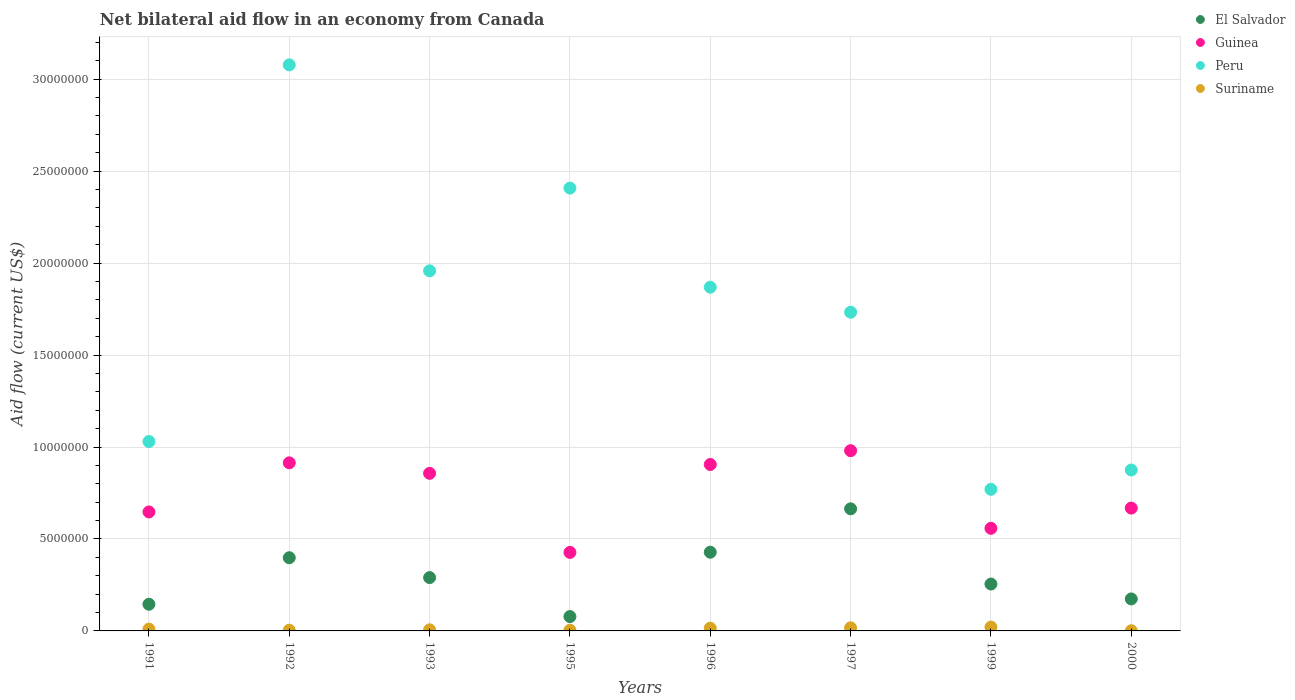Is the number of dotlines equal to the number of legend labels?
Offer a very short reply. Yes. What is the net bilateral aid flow in Peru in 1992?
Provide a short and direct response. 3.08e+07. Across all years, what is the maximum net bilateral aid flow in Suriname?
Provide a short and direct response. 2.10e+05. Across all years, what is the minimum net bilateral aid flow in Peru?
Your response must be concise. 7.70e+06. In which year was the net bilateral aid flow in Guinea minimum?
Your answer should be very brief. 1995. What is the total net bilateral aid flow in Guinea in the graph?
Your answer should be compact. 5.96e+07. What is the difference between the net bilateral aid flow in El Salvador in 1992 and that in 2000?
Offer a very short reply. 2.24e+06. What is the difference between the net bilateral aid flow in El Salvador in 1993 and the net bilateral aid flow in Peru in 1995?
Provide a short and direct response. -2.12e+07. What is the average net bilateral aid flow in Guinea per year?
Provide a succinct answer. 7.44e+06. In the year 1995, what is the difference between the net bilateral aid flow in Guinea and net bilateral aid flow in El Salvador?
Give a very brief answer. 3.49e+06. What is the ratio of the net bilateral aid flow in Peru in 1991 to that in 1999?
Give a very brief answer. 1.34. Is the difference between the net bilateral aid flow in Guinea in 1995 and 1999 greater than the difference between the net bilateral aid flow in El Salvador in 1995 and 1999?
Offer a very short reply. Yes. What is the difference between the highest and the second highest net bilateral aid flow in El Salvador?
Your answer should be compact. 2.36e+06. What is the difference between the highest and the lowest net bilateral aid flow in El Salvador?
Ensure brevity in your answer.  5.86e+06. Is the sum of the net bilateral aid flow in El Salvador in 1996 and 1997 greater than the maximum net bilateral aid flow in Suriname across all years?
Your answer should be very brief. Yes. Is it the case that in every year, the sum of the net bilateral aid flow in Guinea and net bilateral aid flow in Peru  is greater than the sum of net bilateral aid flow in El Salvador and net bilateral aid flow in Suriname?
Your answer should be very brief. Yes. Is the net bilateral aid flow in Guinea strictly greater than the net bilateral aid flow in Suriname over the years?
Your answer should be very brief. Yes. Is the net bilateral aid flow in Guinea strictly less than the net bilateral aid flow in Peru over the years?
Ensure brevity in your answer.  Yes. How many dotlines are there?
Offer a very short reply. 4. How many years are there in the graph?
Provide a short and direct response. 8. What is the difference between two consecutive major ticks on the Y-axis?
Your answer should be very brief. 5.00e+06. Does the graph contain any zero values?
Provide a succinct answer. No. Does the graph contain grids?
Your answer should be very brief. Yes. How many legend labels are there?
Make the answer very short. 4. What is the title of the graph?
Offer a terse response. Net bilateral aid flow in an economy from Canada. Does "Papua New Guinea" appear as one of the legend labels in the graph?
Keep it short and to the point. No. What is the label or title of the X-axis?
Ensure brevity in your answer.  Years. What is the Aid flow (current US$) of El Salvador in 1991?
Your response must be concise. 1.45e+06. What is the Aid flow (current US$) of Guinea in 1991?
Provide a succinct answer. 6.47e+06. What is the Aid flow (current US$) of Peru in 1991?
Your answer should be compact. 1.03e+07. What is the Aid flow (current US$) in Suriname in 1991?
Keep it short and to the point. 1.00e+05. What is the Aid flow (current US$) of El Salvador in 1992?
Your answer should be compact. 3.98e+06. What is the Aid flow (current US$) in Guinea in 1992?
Give a very brief answer. 9.14e+06. What is the Aid flow (current US$) of Peru in 1992?
Offer a terse response. 3.08e+07. What is the Aid flow (current US$) of El Salvador in 1993?
Give a very brief answer. 2.90e+06. What is the Aid flow (current US$) in Guinea in 1993?
Provide a succinct answer. 8.57e+06. What is the Aid flow (current US$) of Peru in 1993?
Give a very brief answer. 1.96e+07. What is the Aid flow (current US$) of Suriname in 1993?
Offer a terse response. 6.00e+04. What is the Aid flow (current US$) of El Salvador in 1995?
Make the answer very short. 7.80e+05. What is the Aid flow (current US$) of Guinea in 1995?
Your response must be concise. 4.27e+06. What is the Aid flow (current US$) of Peru in 1995?
Offer a terse response. 2.41e+07. What is the Aid flow (current US$) of Suriname in 1995?
Provide a short and direct response. 4.00e+04. What is the Aid flow (current US$) in El Salvador in 1996?
Your answer should be compact. 4.28e+06. What is the Aid flow (current US$) of Guinea in 1996?
Provide a short and direct response. 9.05e+06. What is the Aid flow (current US$) of Peru in 1996?
Give a very brief answer. 1.87e+07. What is the Aid flow (current US$) of El Salvador in 1997?
Provide a short and direct response. 6.64e+06. What is the Aid flow (current US$) in Guinea in 1997?
Offer a terse response. 9.80e+06. What is the Aid flow (current US$) in Peru in 1997?
Make the answer very short. 1.73e+07. What is the Aid flow (current US$) in Suriname in 1997?
Ensure brevity in your answer.  1.70e+05. What is the Aid flow (current US$) in El Salvador in 1999?
Provide a short and direct response. 2.55e+06. What is the Aid flow (current US$) of Guinea in 1999?
Provide a short and direct response. 5.58e+06. What is the Aid flow (current US$) of Peru in 1999?
Make the answer very short. 7.70e+06. What is the Aid flow (current US$) of Suriname in 1999?
Ensure brevity in your answer.  2.10e+05. What is the Aid flow (current US$) of El Salvador in 2000?
Offer a very short reply. 1.74e+06. What is the Aid flow (current US$) of Guinea in 2000?
Your response must be concise. 6.68e+06. What is the Aid flow (current US$) of Peru in 2000?
Offer a very short reply. 8.75e+06. Across all years, what is the maximum Aid flow (current US$) in El Salvador?
Give a very brief answer. 6.64e+06. Across all years, what is the maximum Aid flow (current US$) of Guinea?
Make the answer very short. 9.80e+06. Across all years, what is the maximum Aid flow (current US$) of Peru?
Your answer should be compact. 3.08e+07. Across all years, what is the maximum Aid flow (current US$) of Suriname?
Provide a short and direct response. 2.10e+05. Across all years, what is the minimum Aid flow (current US$) of El Salvador?
Provide a short and direct response. 7.80e+05. Across all years, what is the minimum Aid flow (current US$) in Guinea?
Provide a short and direct response. 4.27e+06. Across all years, what is the minimum Aid flow (current US$) in Peru?
Provide a succinct answer. 7.70e+06. What is the total Aid flow (current US$) of El Salvador in the graph?
Provide a succinct answer. 2.43e+07. What is the total Aid flow (current US$) of Guinea in the graph?
Your response must be concise. 5.96e+07. What is the total Aid flow (current US$) of Peru in the graph?
Ensure brevity in your answer.  1.37e+08. What is the total Aid flow (current US$) in Suriname in the graph?
Provide a succinct answer. 7.80e+05. What is the difference between the Aid flow (current US$) of El Salvador in 1991 and that in 1992?
Provide a succinct answer. -2.53e+06. What is the difference between the Aid flow (current US$) in Guinea in 1991 and that in 1992?
Provide a succinct answer. -2.67e+06. What is the difference between the Aid flow (current US$) in Peru in 1991 and that in 1992?
Provide a succinct answer. -2.05e+07. What is the difference between the Aid flow (current US$) in El Salvador in 1991 and that in 1993?
Provide a succinct answer. -1.45e+06. What is the difference between the Aid flow (current US$) in Guinea in 1991 and that in 1993?
Provide a short and direct response. -2.10e+06. What is the difference between the Aid flow (current US$) in Peru in 1991 and that in 1993?
Offer a terse response. -9.28e+06. What is the difference between the Aid flow (current US$) in Suriname in 1991 and that in 1993?
Provide a succinct answer. 4.00e+04. What is the difference between the Aid flow (current US$) in El Salvador in 1991 and that in 1995?
Give a very brief answer. 6.70e+05. What is the difference between the Aid flow (current US$) in Guinea in 1991 and that in 1995?
Provide a short and direct response. 2.20e+06. What is the difference between the Aid flow (current US$) in Peru in 1991 and that in 1995?
Ensure brevity in your answer.  -1.38e+07. What is the difference between the Aid flow (current US$) in Suriname in 1991 and that in 1995?
Offer a terse response. 6.00e+04. What is the difference between the Aid flow (current US$) of El Salvador in 1991 and that in 1996?
Offer a very short reply. -2.83e+06. What is the difference between the Aid flow (current US$) in Guinea in 1991 and that in 1996?
Your response must be concise. -2.58e+06. What is the difference between the Aid flow (current US$) of Peru in 1991 and that in 1996?
Your response must be concise. -8.39e+06. What is the difference between the Aid flow (current US$) in El Salvador in 1991 and that in 1997?
Offer a very short reply. -5.19e+06. What is the difference between the Aid flow (current US$) in Guinea in 1991 and that in 1997?
Offer a very short reply. -3.33e+06. What is the difference between the Aid flow (current US$) of Peru in 1991 and that in 1997?
Provide a succinct answer. -7.03e+06. What is the difference between the Aid flow (current US$) of Suriname in 1991 and that in 1997?
Provide a short and direct response. -7.00e+04. What is the difference between the Aid flow (current US$) in El Salvador in 1991 and that in 1999?
Your answer should be very brief. -1.10e+06. What is the difference between the Aid flow (current US$) of Guinea in 1991 and that in 1999?
Provide a short and direct response. 8.90e+05. What is the difference between the Aid flow (current US$) in Peru in 1991 and that in 1999?
Offer a very short reply. 2.60e+06. What is the difference between the Aid flow (current US$) in Suriname in 1991 and that in 1999?
Give a very brief answer. -1.10e+05. What is the difference between the Aid flow (current US$) of Peru in 1991 and that in 2000?
Your answer should be very brief. 1.55e+06. What is the difference between the Aid flow (current US$) of Suriname in 1991 and that in 2000?
Ensure brevity in your answer.  9.00e+04. What is the difference between the Aid flow (current US$) of El Salvador in 1992 and that in 1993?
Give a very brief answer. 1.08e+06. What is the difference between the Aid flow (current US$) of Guinea in 1992 and that in 1993?
Provide a short and direct response. 5.70e+05. What is the difference between the Aid flow (current US$) of Peru in 1992 and that in 1993?
Keep it short and to the point. 1.12e+07. What is the difference between the Aid flow (current US$) in El Salvador in 1992 and that in 1995?
Keep it short and to the point. 3.20e+06. What is the difference between the Aid flow (current US$) of Guinea in 1992 and that in 1995?
Keep it short and to the point. 4.87e+06. What is the difference between the Aid flow (current US$) in Peru in 1992 and that in 1995?
Your answer should be very brief. 6.70e+06. What is the difference between the Aid flow (current US$) of Suriname in 1992 and that in 1995?
Make the answer very short. 0. What is the difference between the Aid flow (current US$) in Peru in 1992 and that in 1996?
Make the answer very short. 1.21e+07. What is the difference between the Aid flow (current US$) in El Salvador in 1992 and that in 1997?
Ensure brevity in your answer.  -2.66e+06. What is the difference between the Aid flow (current US$) of Guinea in 1992 and that in 1997?
Ensure brevity in your answer.  -6.60e+05. What is the difference between the Aid flow (current US$) in Peru in 1992 and that in 1997?
Your answer should be compact. 1.34e+07. What is the difference between the Aid flow (current US$) in Suriname in 1992 and that in 1997?
Give a very brief answer. -1.30e+05. What is the difference between the Aid flow (current US$) in El Salvador in 1992 and that in 1999?
Provide a succinct answer. 1.43e+06. What is the difference between the Aid flow (current US$) of Guinea in 1992 and that in 1999?
Give a very brief answer. 3.56e+06. What is the difference between the Aid flow (current US$) of Peru in 1992 and that in 1999?
Your answer should be compact. 2.31e+07. What is the difference between the Aid flow (current US$) in Suriname in 1992 and that in 1999?
Provide a short and direct response. -1.70e+05. What is the difference between the Aid flow (current US$) of El Salvador in 1992 and that in 2000?
Give a very brief answer. 2.24e+06. What is the difference between the Aid flow (current US$) of Guinea in 1992 and that in 2000?
Offer a terse response. 2.46e+06. What is the difference between the Aid flow (current US$) in Peru in 1992 and that in 2000?
Keep it short and to the point. 2.20e+07. What is the difference between the Aid flow (current US$) in El Salvador in 1993 and that in 1995?
Make the answer very short. 2.12e+06. What is the difference between the Aid flow (current US$) in Guinea in 1993 and that in 1995?
Keep it short and to the point. 4.30e+06. What is the difference between the Aid flow (current US$) of Peru in 1993 and that in 1995?
Your answer should be compact. -4.50e+06. What is the difference between the Aid flow (current US$) in Suriname in 1993 and that in 1995?
Your answer should be compact. 2.00e+04. What is the difference between the Aid flow (current US$) of El Salvador in 1993 and that in 1996?
Your answer should be compact. -1.38e+06. What is the difference between the Aid flow (current US$) of Guinea in 1993 and that in 1996?
Give a very brief answer. -4.80e+05. What is the difference between the Aid flow (current US$) of Peru in 1993 and that in 1996?
Your answer should be very brief. 8.90e+05. What is the difference between the Aid flow (current US$) in El Salvador in 1993 and that in 1997?
Give a very brief answer. -3.74e+06. What is the difference between the Aid flow (current US$) of Guinea in 1993 and that in 1997?
Provide a short and direct response. -1.23e+06. What is the difference between the Aid flow (current US$) in Peru in 1993 and that in 1997?
Offer a terse response. 2.25e+06. What is the difference between the Aid flow (current US$) in Suriname in 1993 and that in 1997?
Your response must be concise. -1.10e+05. What is the difference between the Aid flow (current US$) of Guinea in 1993 and that in 1999?
Your answer should be compact. 2.99e+06. What is the difference between the Aid flow (current US$) in Peru in 1993 and that in 1999?
Your response must be concise. 1.19e+07. What is the difference between the Aid flow (current US$) in El Salvador in 1993 and that in 2000?
Keep it short and to the point. 1.16e+06. What is the difference between the Aid flow (current US$) in Guinea in 1993 and that in 2000?
Offer a very short reply. 1.89e+06. What is the difference between the Aid flow (current US$) of Peru in 1993 and that in 2000?
Offer a terse response. 1.08e+07. What is the difference between the Aid flow (current US$) in El Salvador in 1995 and that in 1996?
Your answer should be compact. -3.50e+06. What is the difference between the Aid flow (current US$) of Guinea in 1995 and that in 1996?
Offer a terse response. -4.78e+06. What is the difference between the Aid flow (current US$) in Peru in 1995 and that in 1996?
Ensure brevity in your answer.  5.39e+06. What is the difference between the Aid flow (current US$) in Suriname in 1995 and that in 1996?
Provide a short and direct response. -1.10e+05. What is the difference between the Aid flow (current US$) of El Salvador in 1995 and that in 1997?
Provide a short and direct response. -5.86e+06. What is the difference between the Aid flow (current US$) in Guinea in 1995 and that in 1997?
Keep it short and to the point. -5.53e+06. What is the difference between the Aid flow (current US$) in Peru in 1995 and that in 1997?
Offer a very short reply. 6.75e+06. What is the difference between the Aid flow (current US$) in El Salvador in 1995 and that in 1999?
Offer a terse response. -1.77e+06. What is the difference between the Aid flow (current US$) of Guinea in 1995 and that in 1999?
Give a very brief answer. -1.31e+06. What is the difference between the Aid flow (current US$) in Peru in 1995 and that in 1999?
Offer a terse response. 1.64e+07. What is the difference between the Aid flow (current US$) in Suriname in 1995 and that in 1999?
Your answer should be compact. -1.70e+05. What is the difference between the Aid flow (current US$) of El Salvador in 1995 and that in 2000?
Give a very brief answer. -9.60e+05. What is the difference between the Aid flow (current US$) of Guinea in 1995 and that in 2000?
Give a very brief answer. -2.41e+06. What is the difference between the Aid flow (current US$) in Peru in 1995 and that in 2000?
Provide a succinct answer. 1.53e+07. What is the difference between the Aid flow (current US$) of El Salvador in 1996 and that in 1997?
Your answer should be very brief. -2.36e+06. What is the difference between the Aid flow (current US$) in Guinea in 1996 and that in 1997?
Ensure brevity in your answer.  -7.50e+05. What is the difference between the Aid flow (current US$) of Peru in 1996 and that in 1997?
Offer a terse response. 1.36e+06. What is the difference between the Aid flow (current US$) of Suriname in 1996 and that in 1997?
Offer a very short reply. -2.00e+04. What is the difference between the Aid flow (current US$) of El Salvador in 1996 and that in 1999?
Your answer should be compact. 1.73e+06. What is the difference between the Aid flow (current US$) in Guinea in 1996 and that in 1999?
Offer a terse response. 3.47e+06. What is the difference between the Aid flow (current US$) of Peru in 1996 and that in 1999?
Your answer should be very brief. 1.10e+07. What is the difference between the Aid flow (current US$) in El Salvador in 1996 and that in 2000?
Provide a short and direct response. 2.54e+06. What is the difference between the Aid flow (current US$) in Guinea in 1996 and that in 2000?
Ensure brevity in your answer.  2.37e+06. What is the difference between the Aid flow (current US$) in Peru in 1996 and that in 2000?
Offer a very short reply. 9.94e+06. What is the difference between the Aid flow (current US$) in Suriname in 1996 and that in 2000?
Offer a very short reply. 1.40e+05. What is the difference between the Aid flow (current US$) of El Salvador in 1997 and that in 1999?
Your response must be concise. 4.09e+06. What is the difference between the Aid flow (current US$) in Guinea in 1997 and that in 1999?
Ensure brevity in your answer.  4.22e+06. What is the difference between the Aid flow (current US$) of Peru in 1997 and that in 1999?
Your answer should be compact. 9.63e+06. What is the difference between the Aid flow (current US$) in Suriname in 1997 and that in 1999?
Your answer should be very brief. -4.00e+04. What is the difference between the Aid flow (current US$) of El Salvador in 1997 and that in 2000?
Your response must be concise. 4.90e+06. What is the difference between the Aid flow (current US$) in Guinea in 1997 and that in 2000?
Give a very brief answer. 3.12e+06. What is the difference between the Aid flow (current US$) in Peru in 1997 and that in 2000?
Your answer should be very brief. 8.58e+06. What is the difference between the Aid flow (current US$) of El Salvador in 1999 and that in 2000?
Your response must be concise. 8.10e+05. What is the difference between the Aid flow (current US$) of Guinea in 1999 and that in 2000?
Provide a short and direct response. -1.10e+06. What is the difference between the Aid flow (current US$) of Peru in 1999 and that in 2000?
Make the answer very short. -1.05e+06. What is the difference between the Aid flow (current US$) of El Salvador in 1991 and the Aid flow (current US$) of Guinea in 1992?
Ensure brevity in your answer.  -7.69e+06. What is the difference between the Aid flow (current US$) of El Salvador in 1991 and the Aid flow (current US$) of Peru in 1992?
Provide a short and direct response. -2.93e+07. What is the difference between the Aid flow (current US$) of El Salvador in 1991 and the Aid flow (current US$) of Suriname in 1992?
Give a very brief answer. 1.41e+06. What is the difference between the Aid flow (current US$) of Guinea in 1991 and the Aid flow (current US$) of Peru in 1992?
Provide a succinct answer. -2.43e+07. What is the difference between the Aid flow (current US$) in Guinea in 1991 and the Aid flow (current US$) in Suriname in 1992?
Provide a short and direct response. 6.43e+06. What is the difference between the Aid flow (current US$) in Peru in 1991 and the Aid flow (current US$) in Suriname in 1992?
Your response must be concise. 1.03e+07. What is the difference between the Aid flow (current US$) of El Salvador in 1991 and the Aid flow (current US$) of Guinea in 1993?
Make the answer very short. -7.12e+06. What is the difference between the Aid flow (current US$) in El Salvador in 1991 and the Aid flow (current US$) in Peru in 1993?
Your answer should be very brief. -1.81e+07. What is the difference between the Aid flow (current US$) in El Salvador in 1991 and the Aid flow (current US$) in Suriname in 1993?
Offer a terse response. 1.39e+06. What is the difference between the Aid flow (current US$) in Guinea in 1991 and the Aid flow (current US$) in Peru in 1993?
Provide a short and direct response. -1.31e+07. What is the difference between the Aid flow (current US$) of Guinea in 1991 and the Aid flow (current US$) of Suriname in 1993?
Provide a succinct answer. 6.41e+06. What is the difference between the Aid flow (current US$) in Peru in 1991 and the Aid flow (current US$) in Suriname in 1993?
Keep it short and to the point. 1.02e+07. What is the difference between the Aid flow (current US$) of El Salvador in 1991 and the Aid flow (current US$) of Guinea in 1995?
Offer a very short reply. -2.82e+06. What is the difference between the Aid flow (current US$) in El Salvador in 1991 and the Aid flow (current US$) in Peru in 1995?
Give a very brief answer. -2.26e+07. What is the difference between the Aid flow (current US$) of El Salvador in 1991 and the Aid flow (current US$) of Suriname in 1995?
Offer a very short reply. 1.41e+06. What is the difference between the Aid flow (current US$) of Guinea in 1991 and the Aid flow (current US$) of Peru in 1995?
Offer a terse response. -1.76e+07. What is the difference between the Aid flow (current US$) in Guinea in 1991 and the Aid flow (current US$) in Suriname in 1995?
Give a very brief answer. 6.43e+06. What is the difference between the Aid flow (current US$) of Peru in 1991 and the Aid flow (current US$) of Suriname in 1995?
Your answer should be compact. 1.03e+07. What is the difference between the Aid flow (current US$) of El Salvador in 1991 and the Aid flow (current US$) of Guinea in 1996?
Your response must be concise. -7.60e+06. What is the difference between the Aid flow (current US$) in El Salvador in 1991 and the Aid flow (current US$) in Peru in 1996?
Give a very brief answer. -1.72e+07. What is the difference between the Aid flow (current US$) in El Salvador in 1991 and the Aid flow (current US$) in Suriname in 1996?
Offer a very short reply. 1.30e+06. What is the difference between the Aid flow (current US$) of Guinea in 1991 and the Aid flow (current US$) of Peru in 1996?
Your answer should be very brief. -1.22e+07. What is the difference between the Aid flow (current US$) in Guinea in 1991 and the Aid flow (current US$) in Suriname in 1996?
Keep it short and to the point. 6.32e+06. What is the difference between the Aid flow (current US$) in Peru in 1991 and the Aid flow (current US$) in Suriname in 1996?
Give a very brief answer. 1.02e+07. What is the difference between the Aid flow (current US$) of El Salvador in 1991 and the Aid flow (current US$) of Guinea in 1997?
Your answer should be very brief. -8.35e+06. What is the difference between the Aid flow (current US$) of El Salvador in 1991 and the Aid flow (current US$) of Peru in 1997?
Give a very brief answer. -1.59e+07. What is the difference between the Aid flow (current US$) of El Salvador in 1991 and the Aid flow (current US$) of Suriname in 1997?
Your response must be concise. 1.28e+06. What is the difference between the Aid flow (current US$) in Guinea in 1991 and the Aid flow (current US$) in Peru in 1997?
Provide a short and direct response. -1.09e+07. What is the difference between the Aid flow (current US$) in Guinea in 1991 and the Aid flow (current US$) in Suriname in 1997?
Offer a terse response. 6.30e+06. What is the difference between the Aid flow (current US$) in Peru in 1991 and the Aid flow (current US$) in Suriname in 1997?
Offer a very short reply. 1.01e+07. What is the difference between the Aid flow (current US$) of El Salvador in 1991 and the Aid flow (current US$) of Guinea in 1999?
Your answer should be very brief. -4.13e+06. What is the difference between the Aid flow (current US$) of El Salvador in 1991 and the Aid flow (current US$) of Peru in 1999?
Your answer should be very brief. -6.25e+06. What is the difference between the Aid flow (current US$) in El Salvador in 1991 and the Aid flow (current US$) in Suriname in 1999?
Your response must be concise. 1.24e+06. What is the difference between the Aid flow (current US$) in Guinea in 1991 and the Aid flow (current US$) in Peru in 1999?
Make the answer very short. -1.23e+06. What is the difference between the Aid flow (current US$) in Guinea in 1991 and the Aid flow (current US$) in Suriname in 1999?
Offer a very short reply. 6.26e+06. What is the difference between the Aid flow (current US$) of Peru in 1991 and the Aid flow (current US$) of Suriname in 1999?
Ensure brevity in your answer.  1.01e+07. What is the difference between the Aid flow (current US$) of El Salvador in 1991 and the Aid flow (current US$) of Guinea in 2000?
Your response must be concise. -5.23e+06. What is the difference between the Aid flow (current US$) in El Salvador in 1991 and the Aid flow (current US$) in Peru in 2000?
Keep it short and to the point. -7.30e+06. What is the difference between the Aid flow (current US$) of El Salvador in 1991 and the Aid flow (current US$) of Suriname in 2000?
Your answer should be compact. 1.44e+06. What is the difference between the Aid flow (current US$) of Guinea in 1991 and the Aid flow (current US$) of Peru in 2000?
Make the answer very short. -2.28e+06. What is the difference between the Aid flow (current US$) in Guinea in 1991 and the Aid flow (current US$) in Suriname in 2000?
Make the answer very short. 6.46e+06. What is the difference between the Aid flow (current US$) in Peru in 1991 and the Aid flow (current US$) in Suriname in 2000?
Your answer should be very brief. 1.03e+07. What is the difference between the Aid flow (current US$) in El Salvador in 1992 and the Aid flow (current US$) in Guinea in 1993?
Offer a terse response. -4.59e+06. What is the difference between the Aid flow (current US$) of El Salvador in 1992 and the Aid flow (current US$) of Peru in 1993?
Make the answer very short. -1.56e+07. What is the difference between the Aid flow (current US$) in El Salvador in 1992 and the Aid flow (current US$) in Suriname in 1993?
Provide a succinct answer. 3.92e+06. What is the difference between the Aid flow (current US$) in Guinea in 1992 and the Aid flow (current US$) in Peru in 1993?
Ensure brevity in your answer.  -1.04e+07. What is the difference between the Aid flow (current US$) of Guinea in 1992 and the Aid flow (current US$) of Suriname in 1993?
Your answer should be compact. 9.08e+06. What is the difference between the Aid flow (current US$) of Peru in 1992 and the Aid flow (current US$) of Suriname in 1993?
Your answer should be very brief. 3.07e+07. What is the difference between the Aid flow (current US$) in El Salvador in 1992 and the Aid flow (current US$) in Peru in 1995?
Keep it short and to the point. -2.01e+07. What is the difference between the Aid flow (current US$) in El Salvador in 1992 and the Aid flow (current US$) in Suriname in 1995?
Keep it short and to the point. 3.94e+06. What is the difference between the Aid flow (current US$) in Guinea in 1992 and the Aid flow (current US$) in Peru in 1995?
Provide a succinct answer. -1.49e+07. What is the difference between the Aid flow (current US$) in Guinea in 1992 and the Aid flow (current US$) in Suriname in 1995?
Make the answer very short. 9.10e+06. What is the difference between the Aid flow (current US$) of Peru in 1992 and the Aid flow (current US$) of Suriname in 1995?
Your answer should be very brief. 3.07e+07. What is the difference between the Aid flow (current US$) of El Salvador in 1992 and the Aid flow (current US$) of Guinea in 1996?
Ensure brevity in your answer.  -5.07e+06. What is the difference between the Aid flow (current US$) of El Salvador in 1992 and the Aid flow (current US$) of Peru in 1996?
Make the answer very short. -1.47e+07. What is the difference between the Aid flow (current US$) in El Salvador in 1992 and the Aid flow (current US$) in Suriname in 1996?
Your answer should be compact. 3.83e+06. What is the difference between the Aid flow (current US$) in Guinea in 1992 and the Aid flow (current US$) in Peru in 1996?
Offer a terse response. -9.55e+06. What is the difference between the Aid flow (current US$) in Guinea in 1992 and the Aid flow (current US$) in Suriname in 1996?
Make the answer very short. 8.99e+06. What is the difference between the Aid flow (current US$) of Peru in 1992 and the Aid flow (current US$) of Suriname in 1996?
Your response must be concise. 3.06e+07. What is the difference between the Aid flow (current US$) of El Salvador in 1992 and the Aid flow (current US$) of Guinea in 1997?
Ensure brevity in your answer.  -5.82e+06. What is the difference between the Aid flow (current US$) in El Salvador in 1992 and the Aid flow (current US$) in Peru in 1997?
Offer a very short reply. -1.34e+07. What is the difference between the Aid flow (current US$) of El Salvador in 1992 and the Aid flow (current US$) of Suriname in 1997?
Provide a short and direct response. 3.81e+06. What is the difference between the Aid flow (current US$) of Guinea in 1992 and the Aid flow (current US$) of Peru in 1997?
Provide a succinct answer. -8.19e+06. What is the difference between the Aid flow (current US$) in Guinea in 1992 and the Aid flow (current US$) in Suriname in 1997?
Provide a succinct answer. 8.97e+06. What is the difference between the Aid flow (current US$) of Peru in 1992 and the Aid flow (current US$) of Suriname in 1997?
Your response must be concise. 3.06e+07. What is the difference between the Aid flow (current US$) in El Salvador in 1992 and the Aid flow (current US$) in Guinea in 1999?
Offer a terse response. -1.60e+06. What is the difference between the Aid flow (current US$) in El Salvador in 1992 and the Aid flow (current US$) in Peru in 1999?
Offer a terse response. -3.72e+06. What is the difference between the Aid flow (current US$) of El Salvador in 1992 and the Aid flow (current US$) of Suriname in 1999?
Your answer should be very brief. 3.77e+06. What is the difference between the Aid flow (current US$) in Guinea in 1992 and the Aid flow (current US$) in Peru in 1999?
Your answer should be compact. 1.44e+06. What is the difference between the Aid flow (current US$) in Guinea in 1992 and the Aid flow (current US$) in Suriname in 1999?
Your response must be concise. 8.93e+06. What is the difference between the Aid flow (current US$) of Peru in 1992 and the Aid flow (current US$) of Suriname in 1999?
Make the answer very short. 3.06e+07. What is the difference between the Aid flow (current US$) in El Salvador in 1992 and the Aid flow (current US$) in Guinea in 2000?
Keep it short and to the point. -2.70e+06. What is the difference between the Aid flow (current US$) in El Salvador in 1992 and the Aid flow (current US$) in Peru in 2000?
Offer a terse response. -4.77e+06. What is the difference between the Aid flow (current US$) in El Salvador in 1992 and the Aid flow (current US$) in Suriname in 2000?
Make the answer very short. 3.97e+06. What is the difference between the Aid flow (current US$) of Guinea in 1992 and the Aid flow (current US$) of Peru in 2000?
Provide a short and direct response. 3.90e+05. What is the difference between the Aid flow (current US$) in Guinea in 1992 and the Aid flow (current US$) in Suriname in 2000?
Offer a very short reply. 9.13e+06. What is the difference between the Aid flow (current US$) of Peru in 1992 and the Aid flow (current US$) of Suriname in 2000?
Make the answer very short. 3.08e+07. What is the difference between the Aid flow (current US$) of El Salvador in 1993 and the Aid flow (current US$) of Guinea in 1995?
Your answer should be compact. -1.37e+06. What is the difference between the Aid flow (current US$) in El Salvador in 1993 and the Aid flow (current US$) in Peru in 1995?
Ensure brevity in your answer.  -2.12e+07. What is the difference between the Aid flow (current US$) in El Salvador in 1993 and the Aid flow (current US$) in Suriname in 1995?
Make the answer very short. 2.86e+06. What is the difference between the Aid flow (current US$) of Guinea in 1993 and the Aid flow (current US$) of Peru in 1995?
Give a very brief answer. -1.55e+07. What is the difference between the Aid flow (current US$) in Guinea in 1993 and the Aid flow (current US$) in Suriname in 1995?
Keep it short and to the point. 8.53e+06. What is the difference between the Aid flow (current US$) in Peru in 1993 and the Aid flow (current US$) in Suriname in 1995?
Give a very brief answer. 1.95e+07. What is the difference between the Aid flow (current US$) in El Salvador in 1993 and the Aid flow (current US$) in Guinea in 1996?
Give a very brief answer. -6.15e+06. What is the difference between the Aid flow (current US$) in El Salvador in 1993 and the Aid flow (current US$) in Peru in 1996?
Provide a short and direct response. -1.58e+07. What is the difference between the Aid flow (current US$) in El Salvador in 1993 and the Aid flow (current US$) in Suriname in 1996?
Your response must be concise. 2.75e+06. What is the difference between the Aid flow (current US$) of Guinea in 1993 and the Aid flow (current US$) of Peru in 1996?
Provide a succinct answer. -1.01e+07. What is the difference between the Aid flow (current US$) in Guinea in 1993 and the Aid flow (current US$) in Suriname in 1996?
Provide a succinct answer. 8.42e+06. What is the difference between the Aid flow (current US$) in Peru in 1993 and the Aid flow (current US$) in Suriname in 1996?
Offer a very short reply. 1.94e+07. What is the difference between the Aid flow (current US$) in El Salvador in 1993 and the Aid flow (current US$) in Guinea in 1997?
Your answer should be very brief. -6.90e+06. What is the difference between the Aid flow (current US$) in El Salvador in 1993 and the Aid flow (current US$) in Peru in 1997?
Offer a very short reply. -1.44e+07. What is the difference between the Aid flow (current US$) of El Salvador in 1993 and the Aid flow (current US$) of Suriname in 1997?
Provide a succinct answer. 2.73e+06. What is the difference between the Aid flow (current US$) of Guinea in 1993 and the Aid flow (current US$) of Peru in 1997?
Make the answer very short. -8.76e+06. What is the difference between the Aid flow (current US$) of Guinea in 1993 and the Aid flow (current US$) of Suriname in 1997?
Offer a very short reply. 8.40e+06. What is the difference between the Aid flow (current US$) of Peru in 1993 and the Aid flow (current US$) of Suriname in 1997?
Offer a very short reply. 1.94e+07. What is the difference between the Aid flow (current US$) in El Salvador in 1993 and the Aid flow (current US$) in Guinea in 1999?
Your answer should be very brief. -2.68e+06. What is the difference between the Aid flow (current US$) in El Salvador in 1993 and the Aid flow (current US$) in Peru in 1999?
Your response must be concise. -4.80e+06. What is the difference between the Aid flow (current US$) in El Salvador in 1993 and the Aid flow (current US$) in Suriname in 1999?
Keep it short and to the point. 2.69e+06. What is the difference between the Aid flow (current US$) in Guinea in 1993 and the Aid flow (current US$) in Peru in 1999?
Make the answer very short. 8.70e+05. What is the difference between the Aid flow (current US$) of Guinea in 1993 and the Aid flow (current US$) of Suriname in 1999?
Give a very brief answer. 8.36e+06. What is the difference between the Aid flow (current US$) in Peru in 1993 and the Aid flow (current US$) in Suriname in 1999?
Give a very brief answer. 1.94e+07. What is the difference between the Aid flow (current US$) in El Salvador in 1993 and the Aid flow (current US$) in Guinea in 2000?
Your answer should be very brief. -3.78e+06. What is the difference between the Aid flow (current US$) in El Salvador in 1993 and the Aid flow (current US$) in Peru in 2000?
Offer a terse response. -5.85e+06. What is the difference between the Aid flow (current US$) in El Salvador in 1993 and the Aid flow (current US$) in Suriname in 2000?
Give a very brief answer. 2.89e+06. What is the difference between the Aid flow (current US$) of Guinea in 1993 and the Aid flow (current US$) of Peru in 2000?
Give a very brief answer. -1.80e+05. What is the difference between the Aid flow (current US$) in Guinea in 1993 and the Aid flow (current US$) in Suriname in 2000?
Keep it short and to the point. 8.56e+06. What is the difference between the Aid flow (current US$) of Peru in 1993 and the Aid flow (current US$) of Suriname in 2000?
Your answer should be very brief. 1.96e+07. What is the difference between the Aid flow (current US$) in El Salvador in 1995 and the Aid flow (current US$) in Guinea in 1996?
Give a very brief answer. -8.27e+06. What is the difference between the Aid flow (current US$) in El Salvador in 1995 and the Aid flow (current US$) in Peru in 1996?
Your answer should be very brief. -1.79e+07. What is the difference between the Aid flow (current US$) in El Salvador in 1995 and the Aid flow (current US$) in Suriname in 1996?
Your answer should be very brief. 6.30e+05. What is the difference between the Aid flow (current US$) in Guinea in 1995 and the Aid flow (current US$) in Peru in 1996?
Your response must be concise. -1.44e+07. What is the difference between the Aid flow (current US$) of Guinea in 1995 and the Aid flow (current US$) of Suriname in 1996?
Your answer should be very brief. 4.12e+06. What is the difference between the Aid flow (current US$) in Peru in 1995 and the Aid flow (current US$) in Suriname in 1996?
Ensure brevity in your answer.  2.39e+07. What is the difference between the Aid flow (current US$) of El Salvador in 1995 and the Aid flow (current US$) of Guinea in 1997?
Provide a short and direct response. -9.02e+06. What is the difference between the Aid flow (current US$) in El Salvador in 1995 and the Aid flow (current US$) in Peru in 1997?
Provide a short and direct response. -1.66e+07. What is the difference between the Aid flow (current US$) of El Salvador in 1995 and the Aid flow (current US$) of Suriname in 1997?
Provide a succinct answer. 6.10e+05. What is the difference between the Aid flow (current US$) in Guinea in 1995 and the Aid flow (current US$) in Peru in 1997?
Provide a short and direct response. -1.31e+07. What is the difference between the Aid flow (current US$) of Guinea in 1995 and the Aid flow (current US$) of Suriname in 1997?
Provide a short and direct response. 4.10e+06. What is the difference between the Aid flow (current US$) in Peru in 1995 and the Aid flow (current US$) in Suriname in 1997?
Your answer should be very brief. 2.39e+07. What is the difference between the Aid flow (current US$) of El Salvador in 1995 and the Aid flow (current US$) of Guinea in 1999?
Offer a very short reply. -4.80e+06. What is the difference between the Aid flow (current US$) in El Salvador in 1995 and the Aid flow (current US$) in Peru in 1999?
Your answer should be very brief. -6.92e+06. What is the difference between the Aid flow (current US$) in El Salvador in 1995 and the Aid flow (current US$) in Suriname in 1999?
Ensure brevity in your answer.  5.70e+05. What is the difference between the Aid flow (current US$) of Guinea in 1995 and the Aid flow (current US$) of Peru in 1999?
Give a very brief answer. -3.43e+06. What is the difference between the Aid flow (current US$) in Guinea in 1995 and the Aid flow (current US$) in Suriname in 1999?
Your answer should be very brief. 4.06e+06. What is the difference between the Aid flow (current US$) of Peru in 1995 and the Aid flow (current US$) of Suriname in 1999?
Your answer should be very brief. 2.39e+07. What is the difference between the Aid flow (current US$) in El Salvador in 1995 and the Aid flow (current US$) in Guinea in 2000?
Make the answer very short. -5.90e+06. What is the difference between the Aid flow (current US$) in El Salvador in 1995 and the Aid flow (current US$) in Peru in 2000?
Keep it short and to the point. -7.97e+06. What is the difference between the Aid flow (current US$) in El Salvador in 1995 and the Aid flow (current US$) in Suriname in 2000?
Your answer should be compact. 7.70e+05. What is the difference between the Aid flow (current US$) of Guinea in 1995 and the Aid flow (current US$) of Peru in 2000?
Offer a very short reply. -4.48e+06. What is the difference between the Aid flow (current US$) of Guinea in 1995 and the Aid flow (current US$) of Suriname in 2000?
Your answer should be compact. 4.26e+06. What is the difference between the Aid flow (current US$) of Peru in 1995 and the Aid flow (current US$) of Suriname in 2000?
Keep it short and to the point. 2.41e+07. What is the difference between the Aid flow (current US$) of El Salvador in 1996 and the Aid flow (current US$) of Guinea in 1997?
Ensure brevity in your answer.  -5.52e+06. What is the difference between the Aid flow (current US$) in El Salvador in 1996 and the Aid flow (current US$) in Peru in 1997?
Provide a short and direct response. -1.30e+07. What is the difference between the Aid flow (current US$) in El Salvador in 1996 and the Aid flow (current US$) in Suriname in 1997?
Offer a very short reply. 4.11e+06. What is the difference between the Aid flow (current US$) of Guinea in 1996 and the Aid flow (current US$) of Peru in 1997?
Keep it short and to the point. -8.28e+06. What is the difference between the Aid flow (current US$) in Guinea in 1996 and the Aid flow (current US$) in Suriname in 1997?
Offer a very short reply. 8.88e+06. What is the difference between the Aid flow (current US$) in Peru in 1996 and the Aid flow (current US$) in Suriname in 1997?
Your answer should be very brief. 1.85e+07. What is the difference between the Aid flow (current US$) of El Salvador in 1996 and the Aid flow (current US$) of Guinea in 1999?
Your answer should be compact. -1.30e+06. What is the difference between the Aid flow (current US$) of El Salvador in 1996 and the Aid flow (current US$) of Peru in 1999?
Keep it short and to the point. -3.42e+06. What is the difference between the Aid flow (current US$) of El Salvador in 1996 and the Aid flow (current US$) of Suriname in 1999?
Keep it short and to the point. 4.07e+06. What is the difference between the Aid flow (current US$) of Guinea in 1996 and the Aid flow (current US$) of Peru in 1999?
Your answer should be very brief. 1.35e+06. What is the difference between the Aid flow (current US$) of Guinea in 1996 and the Aid flow (current US$) of Suriname in 1999?
Give a very brief answer. 8.84e+06. What is the difference between the Aid flow (current US$) of Peru in 1996 and the Aid flow (current US$) of Suriname in 1999?
Make the answer very short. 1.85e+07. What is the difference between the Aid flow (current US$) in El Salvador in 1996 and the Aid flow (current US$) in Guinea in 2000?
Keep it short and to the point. -2.40e+06. What is the difference between the Aid flow (current US$) of El Salvador in 1996 and the Aid flow (current US$) of Peru in 2000?
Your response must be concise. -4.47e+06. What is the difference between the Aid flow (current US$) of El Salvador in 1996 and the Aid flow (current US$) of Suriname in 2000?
Provide a short and direct response. 4.27e+06. What is the difference between the Aid flow (current US$) in Guinea in 1996 and the Aid flow (current US$) in Peru in 2000?
Ensure brevity in your answer.  3.00e+05. What is the difference between the Aid flow (current US$) of Guinea in 1996 and the Aid flow (current US$) of Suriname in 2000?
Ensure brevity in your answer.  9.04e+06. What is the difference between the Aid flow (current US$) in Peru in 1996 and the Aid flow (current US$) in Suriname in 2000?
Make the answer very short. 1.87e+07. What is the difference between the Aid flow (current US$) in El Salvador in 1997 and the Aid flow (current US$) in Guinea in 1999?
Your response must be concise. 1.06e+06. What is the difference between the Aid flow (current US$) of El Salvador in 1997 and the Aid flow (current US$) of Peru in 1999?
Your response must be concise. -1.06e+06. What is the difference between the Aid flow (current US$) of El Salvador in 1997 and the Aid flow (current US$) of Suriname in 1999?
Provide a succinct answer. 6.43e+06. What is the difference between the Aid flow (current US$) of Guinea in 1997 and the Aid flow (current US$) of Peru in 1999?
Your response must be concise. 2.10e+06. What is the difference between the Aid flow (current US$) in Guinea in 1997 and the Aid flow (current US$) in Suriname in 1999?
Make the answer very short. 9.59e+06. What is the difference between the Aid flow (current US$) in Peru in 1997 and the Aid flow (current US$) in Suriname in 1999?
Your answer should be compact. 1.71e+07. What is the difference between the Aid flow (current US$) of El Salvador in 1997 and the Aid flow (current US$) of Guinea in 2000?
Give a very brief answer. -4.00e+04. What is the difference between the Aid flow (current US$) of El Salvador in 1997 and the Aid flow (current US$) of Peru in 2000?
Make the answer very short. -2.11e+06. What is the difference between the Aid flow (current US$) of El Salvador in 1997 and the Aid flow (current US$) of Suriname in 2000?
Your answer should be compact. 6.63e+06. What is the difference between the Aid flow (current US$) in Guinea in 1997 and the Aid flow (current US$) in Peru in 2000?
Your answer should be very brief. 1.05e+06. What is the difference between the Aid flow (current US$) in Guinea in 1997 and the Aid flow (current US$) in Suriname in 2000?
Your answer should be very brief. 9.79e+06. What is the difference between the Aid flow (current US$) in Peru in 1997 and the Aid flow (current US$) in Suriname in 2000?
Make the answer very short. 1.73e+07. What is the difference between the Aid flow (current US$) in El Salvador in 1999 and the Aid flow (current US$) in Guinea in 2000?
Provide a succinct answer. -4.13e+06. What is the difference between the Aid flow (current US$) of El Salvador in 1999 and the Aid flow (current US$) of Peru in 2000?
Your answer should be compact. -6.20e+06. What is the difference between the Aid flow (current US$) in El Salvador in 1999 and the Aid flow (current US$) in Suriname in 2000?
Give a very brief answer. 2.54e+06. What is the difference between the Aid flow (current US$) of Guinea in 1999 and the Aid flow (current US$) of Peru in 2000?
Offer a terse response. -3.17e+06. What is the difference between the Aid flow (current US$) in Guinea in 1999 and the Aid flow (current US$) in Suriname in 2000?
Your answer should be compact. 5.57e+06. What is the difference between the Aid flow (current US$) of Peru in 1999 and the Aid flow (current US$) of Suriname in 2000?
Offer a terse response. 7.69e+06. What is the average Aid flow (current US$) in El Salvador per year?
Give a very brief answer. 3.04e+06. What is the average Aid flow (current US$) in Guinea per year?
Offer a very short reply. 7.44e+06. What is the average Aid flow (current US$) in Peru per year?
Your response must be concise. 1.72e+07. What is the average Aid flow (current US$) of Suriname per year?
Your answer should be compact. 9.75e+04. In the year 1991, what is the difference between the Aid flow (current US$) in El Salvador and Aid flow (current US$) in Guinea?
Provide a short and direct response. -5.02e+06. In the year 1991, what is the difference between the Aid flow (current US$) in El Salvador and Aid flow (current US$) in Peru?
Provide a short and direct response. -8.85e+06. In the year 1991, what is the difference between the Aid flow (current US$) in El Salvador and Aid flow (current US$) in Suriname?
Offer a terse response. 1.35e+06. In the year 1991, what is the difference between the Aid flow (current US$) in Guinea and Aid flow (current US$) in Peru?
Offer a very short reply. -3.83e+06. In the year 1991, what is the difference between the Aid flow (current US$) of Guinea and Aid flow (current US$) of Suriname?
Offer a very short reply. 6.37e+06. In the year 1991, what is the difference between the Aid flow (current US$) of Peru and Aid flow (current US$) of Suriname?
Offer a terse response. 1.02e+07. In the year 1992, what is the difference between the Aid flow (current US$) of El Salvador and Aid flow (current US$) of Guinea?
Your response must be concise. -5.16e+06. In the year 1992, what is the difference between the Aid flow (current US$) of El Salvador and Aid flow (current US$) of Peru?
Your answer should be compact. -2.68e+07. In the year 1992, what is the difference between the Aid flow (current US$) of El Salvador and Aid flow (current US$) of Suriname?
Your answer should be compact. 3.94e+06. In the year 1992, what is the difference between the Aid flow (current US$) in Guinea and Aid flow (current US$) in Peru?
Ensure brevity in your answer.  -2.16e+07. In the year 1992, what is the difference between the Aid flow (current US$) in Guinea and Aid flow (current US$) in Suriname?
Provide a short and direct response. 9.10e+06. In the year 1992, what is the difference between the Aid flow (current US$) of Peru and Aid flow (current US$) of Suriname?
Keep it short and to the point. 3.07e+07. In the year 1993, what is the difference between the Aid flow (current US$) in El Salvador and Aid flow (current US$) in Guinea?
Give a very brief answer. -5.67e+06. In the year 1993, what is the difference between the Aid flow (current US$) of El Salvador and Aid flow (current US$) of Peru?
Keep it short and to the point. -1.67e+07. In the year 1993, what is the difference between the Aid flow (current US$) in El Salvador and Aid flow (current US$) in Suriname?
Provide a succinct answer. 2.84e+06. In the year 1993, what is the difference between the Aid flow (current US$) in Guinea and Aid flow (current US$) in Peru?
Offer a terse response. -1.10e+07. In the year 1993, what is the difference between the Aid flow (current US$) in Guinea and Aid flow (current US$) in Suriname?
Offer a very short reply. 8.51e+06. In the year 1993, what is the difference between the Aid flow (current US$) of Peru and Aid flow (current US$) of Suriname?
Keep it short and to the point. 1.95e+07. In the year 1995, what is the difference between the Aid flow (current US$) of El Salvador and Aid flow (current US$) of Guinea?
Make the answer very short. -3.49e+06. In the year 1995, what is the difference between the Aid flow (current US$) in El Salvador and Aid flow (current US$) in Peru?
Provide a short and direct response. -2.33e+07. In the year 1995, what is the difference between the Aid flow (current US$) of El Salvador and Aid flow (current US$) of Suriname?
Ensure brevity in your answer.  7.40e+05. In the year 1995, what is the difference between the Aid flow (current US$) of Guinea and Aid flow (current US$) of Peru?
Offer a terse response. -1.98e+07. In the year 1995, what is the difference between the Aid flow (current US$) of Guinea and Aid flow (current US$) of Suriname?
Ensure brevity in your answer.  4.23e+06. In the year 1995, what is the difference between the Aid flow (current US$) in Peru and Aid flow (current US$) in Suriname?
Your answer should be very brief. 2.40e+07. In the year 1996, what is the difference between the Aid flow (current US$) in El Salvador and Aid flow (current US$) in Guinea?
Give a very brief answer. -4.77e+06. In the year 1996, what is the difference between the Aid flow (current US$) of El Salvador and Aid flow (current US$) of Peru?
Your response must be concise. -1.44e+07. In the year 1996, what is the difference between the Aid flow (current US$) in El Salvador and Aid flow (current US$) in Suriname?
Provide a short and direct response. 4.13e+06. In the year 1996, what is the difference between the Aid flow (current US$) in Guinea and Aid flow (current US$) in Peru?
Give a very brief answer. -9.64e+06. In the year 1996, what is the difference between the Aid flow (current US$) of Guinea and Aid flow (current US$) of Suriname?
Provide a short and direct response. 8.90e+06. In the year 1996, what is the difference between the Aid flow (current US$) of Peru and Aid flow (current US$) of Suriname?
Ensure brevity in your answer.  1.85e+07. In the year 1997, what is the difference between the Aid flow (current US$) in El Salvador and Aid flow (current US$) in Guinea?
Ensure brevity in your answer.  -3.16e+06. In the year 1997, what is the difference between the Aid flow (current US$) in El Salvador and Aid flow (current US$) in Peru?
Provide a succinct answer. -1.07e+07. In the year 1997, what is the difference between the Aid flow (current US$) of El Salvador and Aid flow (current US$) of Suriname?
Offer a terse response. 6.47e+06. In the year 1997, what is the difference between the Aid flow (current US$) of Guinea and Aid flow (current US$) of Peru?
Make the answer very short. -7.53e+06. In the year 1997, what is the difference between the Aid flow (current US$) of Guinea and Aid flow (current US$) of Suriname?
Your answer should be very brief. 9.63e+06. In the year 1997, what is the difference between the Aid flow (current US$) in Peru and Aid flow (current US$) in Suriname?
Keep it short and to the point. 1.72e+07. In the year 1999, what is the difference between the Aid flow (current US$) of El Salvador and Aid flow (current US$) of Guinea?
Give a very brief answer. -3.03e+06. In the year 1999, what is the difference between the Aid flow (current US$) in El Salvador and Aid flow (current US$) in Peru?
Offer a very short reply. -5.15e+06. In the year 1999, what is the difference between the Aid flow (current US$) in El Salvador and Aid flow (current US$) in Suriname?
Keep it short and to the point. 2.34e+06. In the year 1999, what is the difference between the Aid flow (current US$) of Guinea and Aid flow (current US$) of Peru?
Provide a short and direct response. -2.12e+06. In the year 1999, what is the difference between the Aid flow (current US$) of Guinea and Aid flow (current US$) of Suriname?
Your answer should be very brief. 5.37e+06. In the year 1999, what is the difference between the Aid flow (current US$) of Peru and Aid flow (current US$) of Suriname?
Offer a very short reply. 7.49e+06. In the year 2000, what is the difference between the Aid flow (current US$) of El Salvador and Aid flow (current US$) of Guinea?
Ensure brevity in your answer.  -4.94e+06. In the year 2000, what is the difference between the Aid flow (current US$) in El Salvador and Aid flow (current US$) in Peru?
Keep it short and to the point. -7.01e+06. In the year 2000, what is the difference between the Aid flow (current US$) of El Salvador and Aid flow (current US$) of Suriname?
Your response must be concise. 1.73e+06. In the year 2000, what is the difference between the Aid flow (current US$) in Guinea and Aid flow (current US$) in Peru?
Provide a short and direct response. -2.07e+06. In the year 2000, what is the difference between the Aid flow (current US$) in Guinea and Aid flow (current US$) in Suriname?
Ensure brevity in your answer.  6.67e+06. In the year 2000, what is the difference between the Aid flow (current US$) in Peru and Aid flow (current US$) in Suriname?
Offer a very short reply. 8.74e+06. What is the ratio of the Aid flow (current US$) in El Salvador in 1991 to that in 1992?
Keep it short and to the point. 0.36. What is the ratio of the Aid flow (current US$) in Guinea in 1991 to that in 1992?
Offer a terse response. 0.71. What is the ratio of the Aid flow (current US$) in Peru in 1991 to that in 1992?
Your answer should be very brief. 0.33. What is the ratio of the Aid flow (current US$) of Suriname in 1991 to that in 1992?
Your response must be concise. 2.5. What is the ratio of the Aid flow (current US$) in Guinea in 1991 to that in 1993?
Your answer should be very brief. 0.76. What is the ratio of the Aid flow (current US$) of Peru in 1991 to that in 1993?
Give a very brief answer. 0.53. What is the ratio of the Aid flow (current US$) of El Salvador in 1991 to that in 1995?
Your response must be concise. 1.86. What is the ratio of the Aid flow (current US$) of Guinea in 1991 to that in 1995?
Your answer should be very brief. 1.52. What is the ratio of the Aid flow (current US$) of Peru in 1991 to that in 1995?
Your response must be concise. 0.43. What is the ratio of the Aid flow (current US$) in El Salvador in 1991 to that in 1996?
Give a very brief answer. 0.34. What is the ratio of the Aid flow (current US$) of Guinea in 1991 to that in 1996?
Your response must be concise. 0.71. What is the ratio of the Aid flow (current US$) in Peru in 1991 to that in 1996?
Your response must be concise. 0.55. What is the ratio of the Aid flow (current US$) of Suriname in 1991 to that in 1996?
Provide a short and direct response. 0.67. What is the ratio of the Aid flow (current US$) of El Salvador in 1991 to that in 1997?
Offer a very short reply. 0.22. What is the ratio of the Aid flow (current US$) in Guinea in 1991 to that in 1997?
Your response must be concise. 0.66. What is the ratio of the Aid flow (current US$) of Peru in 1991 to that in 1997?
Offer a terse response. 0.59. What is the ratio of the Aid flow (current US$) of Suriname in 1991 to that in 1997?
Keep it short and to the point. 0.59. What is the ratio of the Aid flow (current US$) in El Salvador in 1991 to that in 1999?
Ensure brevity in your answer.  0.57. What is the ratio of the Aid flow (current US$) of Guinea in 1991 to that in 1999?
Your answer should be very brief. 1.16. What is the ratio of the Aid flow (current US$) in Peru in 1991 to that in 1999?
Make the answer very short. 1.34. What is the ratio of the Aid flow (current US$) of Suriname in 1991 to that in 1999?
Make the answer very short. 0.48. What is the ratio of the Aid flow (current US$) of Guinea in 1991 to that in 2000?
Give a very brief answer. 0.97. What is the ratio of the Aid flow (current US$) of Peru in 1991 to that in 2000?
Keep it short and to the point. 1.18. What is the ratio of the Aid flow (current US$) in El Salvador in 1992 to that in 1993?
Keep it short and to the point. 1.37. What is the ratio of the Aid flow (current US$) of Guinea in 1992 to that in 1993?
Offer a very short reply. 1.07. What is the ratio of the Aid flow (current US$) in Peru in 1992 to that in 1993?
Provide a succinct answer. 1.57. What is the ratio of the Aid flow (current US$) in Suriname in 1992 to that in 1993?
Your response must be concise. 0.67. What is the ratio of the Aid flow (current US$) in El Salvador in 1992 to that in 1995?
Your answer should be compact. 5.1. What is the ratio of the Aid flow (current US$) in Guinea in 1992 to that in 1995?
Your answer should be very brief. 2.14. What is the ratio of the Aid flow (current US$) in Peru in 1992 to that in 1995?
Ensure brevity in your answer.  1.28. What is the ratio of the Aid flow (current US$) of El Salvador in 1992 to that in 1996?
Offer a terse response. 0.93. What is the ratio of the Aid flow (current US$) in Guinea in 1992 to that in 1996?
Make the answer very short. 1.01. What is the ratio of the Aid flow (current US$) in Peru in 1992 to that in 1996?
Make the answer very short. 1.65. What is the ratio of the Aid flow (current US$) in Suriname in 1992 to that in 1996?
Keep it short and to the point. 0.27. What is the ratio of the Aid flow (current US$) in El Salvador in 1992 to that in 1997?
Your response must be concise. 0.6. What is the ratio of the Aid flow (current US$) in Guinea in 1992 to that in 1997?
Give a very brief answer. 0.93. What is the ratio of the Aid flow (current US$) of Peru in 1992 to that in 1997?
Your answer should be compact. 1.78. What is the ratio of the Aid flow (current US$) in Suriname in 1992 to that in 1997?
Provide a short and direct response. 0.24. What is the ratio of the Aid flow (current US$) of El Salvador in 1992 to that in 1999?
Offer a very short reply. 1.56. What is the ratio of the Aid flow (current US$) in Guinea in 1992 to that in 1999?
Your response must be concise. 1.64. What is the ratio of the Aid flow (current US$) in Peru in 1992 to that in 1999?
Give a very brief answer. 4. What is the ratio of the Aid flow (current US$) in Suriname in 1992 to that in 1999?
Keep it short and to the point. 0.19. What is the ratio of the Aid flow (current US$) in El Salvador in 1992 to that in 2000?
Your response must be concise. 2.29. What is the ratio of the Aid flow (current US$) of Guinea in 1992 to that in 2000?
Your response must be concise. 1.37. What is the ratio of the Aid flow (current US$) of Peru in 1992 to that in 2000?
Your answer should be compact. 3.52. What is the ratio of the Aid flow (current US$) of Suriname in 1992 to that in 2000?
Give a very brief answer. 4. What is the ratio of the Aid flow (current US$) of El Salvador in 1993 to that in 1995?
Your answer should be very brief. 3.72. What is the ratio of the Aid flow (current US$) in Guinea in 1993 to that in 1995?
Give a very brief answer. 2.01. What is the ratio of the Aid flow (current US$) in Peru in 1993 to that in 1995?
Keep it short and to the point. 0.81. What is the ratio of the Aid flow (current US$) of El Salvador in 1993 to that in 1996?
Your answer should be compact. 0.68. What is the ratio of the Aid flow (current US$) of Guinea in 1993 to that in 1996?
Give a very brief answer. 0.95. What is the ratio of the Aid flow (current US$) of Peru in 1993 to that in 1996?
Make the answer very short. 1.05. What is the ratio of the Aid flow (current US$) of Suriname in 1993 to that in 1996?
Ensure brevity in your answer.  0.4. What is the ratio of the Aid flow (current US$) of El Salvador in 1993 to that in 1997?
Provide a short and direct response. 0.44. What is the ratio of the Aid flow (current US$) in Guinea in 1993 to that in 1997?
Give a very brief answer. 0.87. What is the ratio of the Aid flow (current US$) of Peru in 1993 to that in 1997?
Your response must be concise. 1.13. What is the ratio of the Aid flow (current US$) in Suriname in 1993 to that in 1997?
Offer a terse response. 0.35. What is the ratio of the Aid flow (current US$) of El Salvador in 1993 to that in 1999?
Offer a very short reply. 1.14. What is the ratio of the Aid flow (current US$) in Guinea in 1993 to that in 1999?
Give a very brief answer. 1.54. What is the ratio of the Aid flow (current US$) of Peru in 1993 to that in 1999?
Your answer should be compact. 2.54. What is the ratio of the Aid flow (current US$) of Suriname in 1993 to that in 1999?
Provide a succinct answer. 0.29. What is the ratio of the Aid flow (current US$) in Guinea in 1993 to that in 2000?
Your response must be concise. 1.28. What is the ratio of the Aid flow (current US$) of Peru in 1993 to that in 2000?
Provide a short and direct response. 2.24. What is the ratio of the Aid flow (current US$) of El Salvador in 1995 to that in 1996?
Your answer should be compact. 0.18. What is the ratio of the Aid flow (current US$) in Guinea in 1995 to that in 1996?
Your response must be concise. 0.47. What is the ratio of the Aid flow (current US$) of Peru in 1995 to that in 1996?
Your answer should be very brief. 1.29. What is the ratio of the Aid flow (current US$) of Suriname in 1995 to that in 1996?
Offer a terse response. 0.27. What is the ratio of the Aid flow (current US$) of El Salvador in 1995 to that in 1997?
Your answer should be very brief. 0.12. What is the ratio of the Aid flow (current US$) in Guinea in 1995 to that in 1997?
Ensure brevity in your answer.  0.44. What is the ratio of the Aid flow (current US$) in Peru in 1995 to that in 1997?
Give a very brief answer. 1.39. What is the ratio of the Aid flow (current US$) of Suriname in 1995 to that in 1997?
Provide a short and direct response. 0.24. What is the ratio of the Aid flow (current US$) in El Salvador in 1995 to that in 1999?
Provide a succinct answer. 0.31. What is the ratio of the Aid flow (current US$) in Guinea in 1995 to that in 1999?
Ensure brevity in your answer.  0.77. What is the ratio of the Aid flow (current US$) of Peru in 1995 to that in 1999?
Your answer should be compact. 3.13. What is the ratio of the Aid flow (current US$) in Suriname in 1995 to that in 1999?
Ensure brevity in your answer.  0.19. What is the ratio of the Aid flow (current US$) in El Salvador in 1995 to that in 2000?
Offer a very short reply. 0.45. What is the ratio of the Aid flow (current US$) of Guinea in 1995 to that in 2000?
Provide a succinct answer. 0.64. What is the ratio of the Aid flow (current US$) in Peru in 1995 to that in 2000?
Your response must be concise. 2.75. What is the ratio of the Aid flow (current US$) in Suriname in 1995 to that in 2000?
Provide a succinct answer. 4. What is the ratio of the Aid flow (current US$) of El Salvador in 1996 to that in 1997?
Make the answer very short. 0.64. What is the ratio of the Aid flow (current US$) of Guinea in 1996 to that in 1997?
Provide a short and direct response. 0.92. What is the ratio of the Aid flow (current US$) in Peru in 1996 to that in 1997?
Offer a very short reply. 1.08. What is the ratio of the Aid flow (current US$) in Suriname in 1996 to that in 1997?
Your answer should be compact. 0.88. What is the ratio of the Aid flow (current US$) in El Salvador in 1996 to that in 1999?
Offer a terse response. 1.68. What is the ratio of the Aid flow (current US$) in Guinea in 1996 to that in 1999?
Provide a short and direct response. 1.62. What is the ratio of the Aid flow (current US$) of Peru in 1996 to that in 1999?
Keep it short and to the point. 2.43. What is the ratio of the Aid flow (current US$) in El Salvador in 1996 to that in 2000?
Provide a short and direct response. 2.46. What is the ratio of the Aid flow (current US$) of Guinea in 1996 to that in 2000?
Your answer should be compact. 1.35. What is the ratio of the Aid flow (current US$) of Peru in 1996 to that in 2000?
Offer a terse response. 2.14. What is the ratio of the Aid flow (current US$) of El Salvador in 1997 to that in 1999?
Your response must be concise. 2.6. What is the ratio of the Aid flow (current US$) of Guinea in 1997 to that in 1999?
Offer a terse response. 1.76. What is the ratio of the Aid flow (current US$) of Peru in 1997 to that in 1999?
Offer a very short reply. 2.25. What is the ratio of the Aid flow (current US$) in Suriname in 1997 to that in 1999?
Ensure brevity in your answer.  0.81. What is the ratio of the Aid flow (current US$) in El Salvador in 1997 to that in 2000?
Provide a short and direct response. 3.82. What is the ratio of the Aid flow (current US$) of Guinea in 1997 to that in 2000?
Your answer should be compact. 1.47. What is the ratio of the Aid flow (current US$) in Peru in 1997 to that in 2000?
Ensure brevity in your answer.  1.98. What is the ratio of the Aid flow (current US$) in El Salvador in 1999 to that in 2000?
Your response must be concise. 1.47. What is the ratio of the Aid flow (current US$) of Guinea in 1999 to that in 2000?
Provide a short and direct response. 0.84. What is the ratio of the Aid flow (current US$) in Peru in 1999 to that in 2000?
Provide a short and direct response. 0.88. What is the difference between the highest and the second highest Aid flow (current US$) in El Salvador?
Your answer should be compact. 2.36e+06. What is the difference between the highest and the second highest Aid flow (current US$) in Peru?
Provide a succinct answer. 6.70e+06. What is the difference between the highest and the lowest Aid flow (current US$) in El Salvador?
Make the answer very short. 5.86e+06. What is the difference between the highest and the lowest Aid flow (current US$) in Guinea?
Offer a terse response. 5.53e+06. What is the difference between the highest and the lowest Aid flow (current US$) in Peru?
Ensure brevity in your answer.  2.31e+07. 